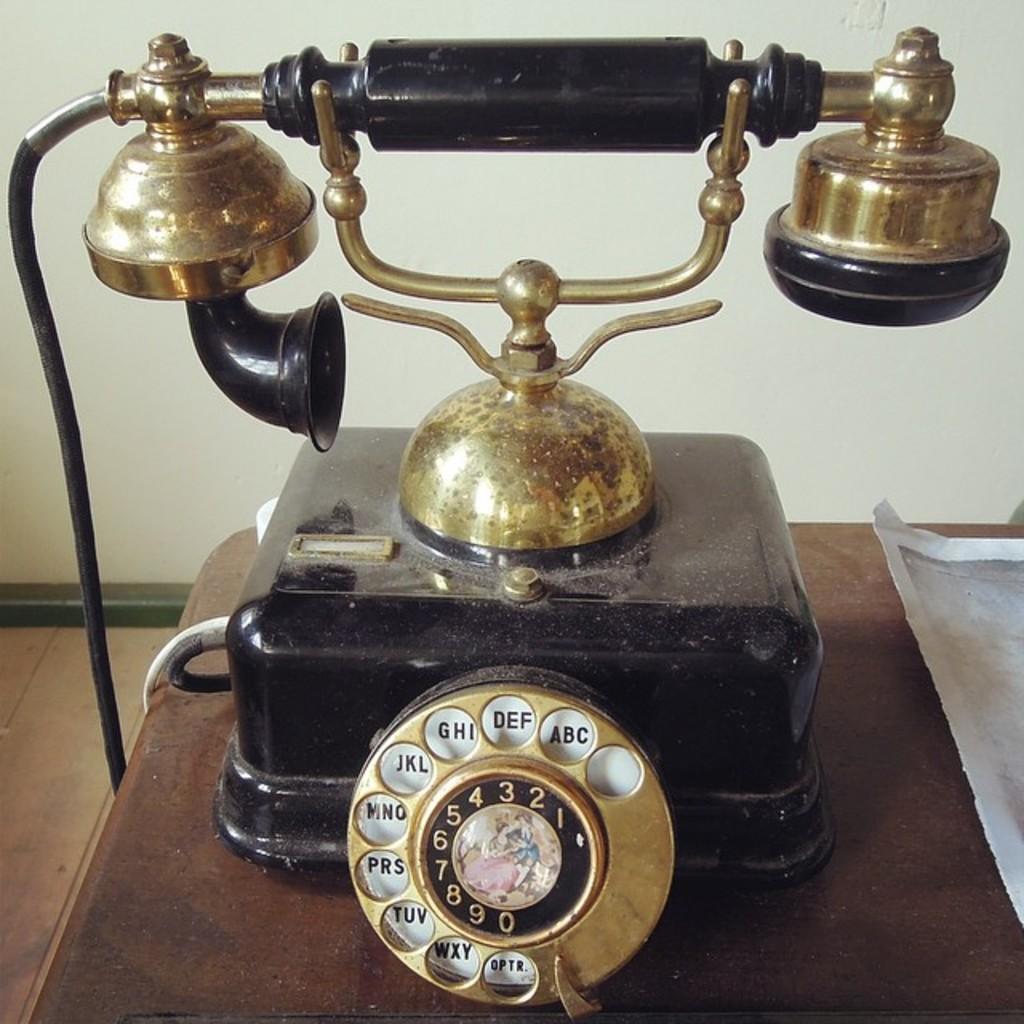In one or two sentences, can you explain what this image depicts? In this image in the foreground there is a telephone, and at the bottom there is a table and paper. And in the background there is wall, and on the left side of the image there is floor. 